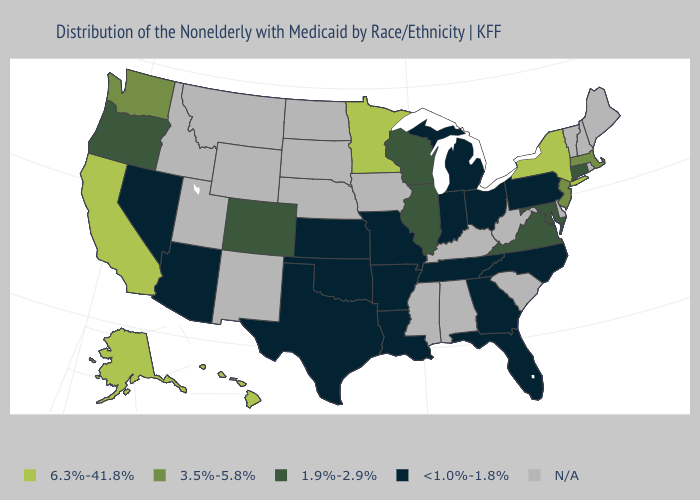What is the value of New Hampshire?
Short answer required. N/A. What is the value of South Dakota?
Be succinct. N/A. What is the value of New Hampshire?
Keep it brief. N/A. Name the states that have a value in the range <1.0%-1.8%?
Quick response, please. Arizona, Arkansas, Florida, Georgia, Indiana, Kansas, Louisiana, Michigan, Missouri, Nevada, North Carolina, Ohio, Oklahoma, Pennsylvania, Tennessee, Texas. What is the value of Iowa?
Write a very short answer. N/A. What is the value of Illinois?
Keep it brief. 1.9%-2.9%. Among the states that border Oregon , does California have the highest value?
Be succinct. Yes. What is the value of Wyoming?
Short answer required. N/A. Which states hav the highest value in the South?
Be succinct. Maryland, Virginia. What is the highest value in the South ?
Keep it brief. 1.9%-2.9%. Among the states that border Idaho , does Oregon have the highest value?
Write a very short answer. No. Name the states that have a value in the range 3.5%-5.8%?
Short answer required. Massachusetts, New Jersey, Washington. Among the states that border Utah , which have the highest value?
Short answer required. Colorado. 